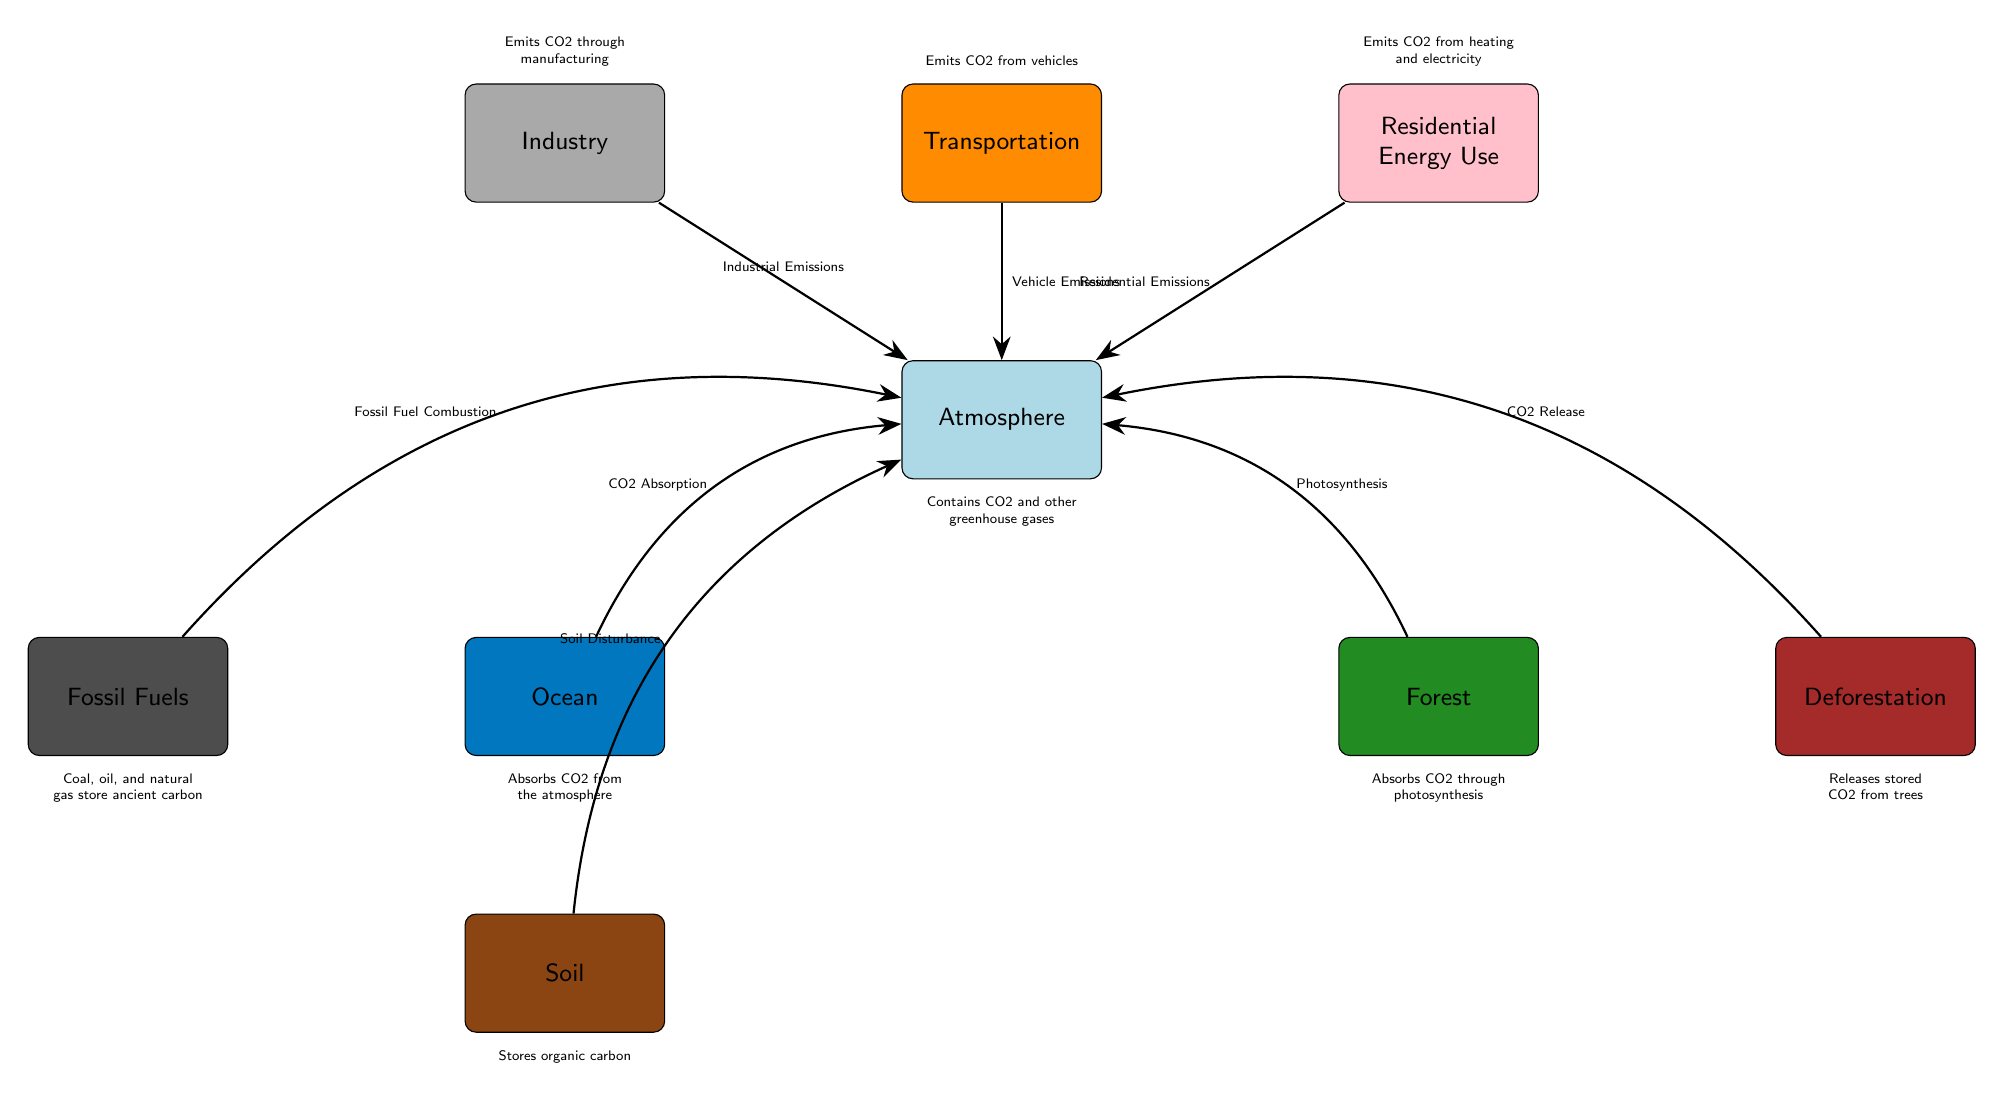What is the main source of carbon dioxide emissions from the transportation sector? According to the diagram, the transportation sector emits carbon dioxide through vehicle emissions.
Answer: Vehicle Emissions How many carbon sinks are represented in the diagram? The diagram has three carbon sinks: Ocean, Forest, and Soil.
Answer: 3 Which process associated with the forest contributes to carbon dioxide absorption? The diagram shows that photosynthesis is the process through which the forest absorbs carbon dioxide from the atmosphere.
Answer: Photosynthesis What is the relationship between soil disturbance and carbon dioxide? The diagram indicates that soil disturbance contributes to the release of carbon dioxide into the atmosphere.
Answer: Soil Disturbance Identify the node that represents fossil fuel combustion. The node labeled "Fossil Fuels" represents the process of fossil fuel combustion, which is linked to carbon dioxide emissions.
Answer: Fossil Fuel Combustion Explain how deforestation affects carbon levels in the atmosphere. The diagram shows that deforestation leads to the release of stored carbon dioxide, thereby increasing the amount of carbon dioxide present in the atmosphere.
Answer: CO2 Release Which carbon sink absorbs CO2 directly from the atmosphere? The Ocean is identified in the diagram as absorbing carbon dioxide directly from the atmosphere.
Answer: Ocean What do industrial activities contribute to the atmosphere according to the diagram? The diagram specifies that industrial emissions are a contributing factor to carbon dioxide levels in the atmosphere.
Answer: Industrial Emissions Which human activity emits carbon dioxide from residential energy use? The diagram attributes carbon dioxide emissions from heating and electricity usage to residential energy use.
Answer: Residential Emissions 